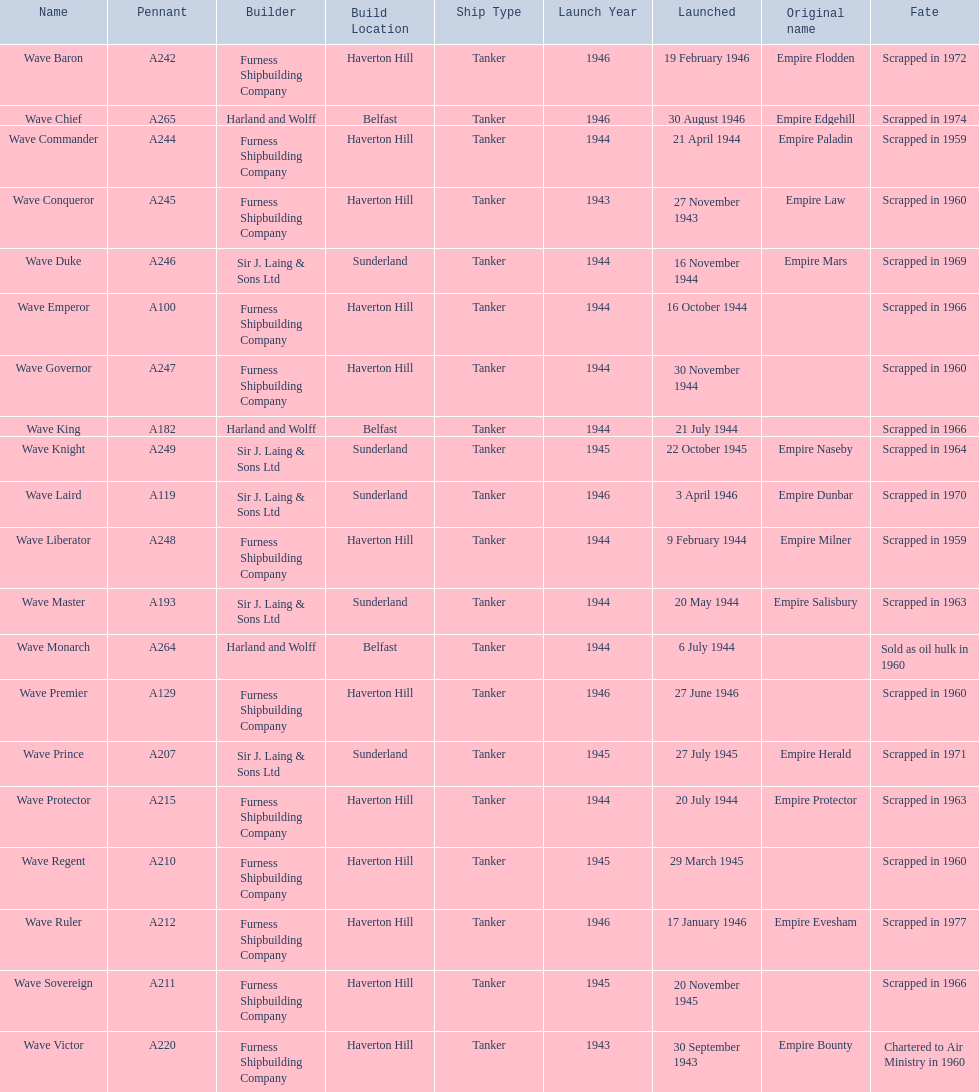What date was the wave victor launched? 30 September 1943. What other oiler was launched that same year? Wave Conqueror. 